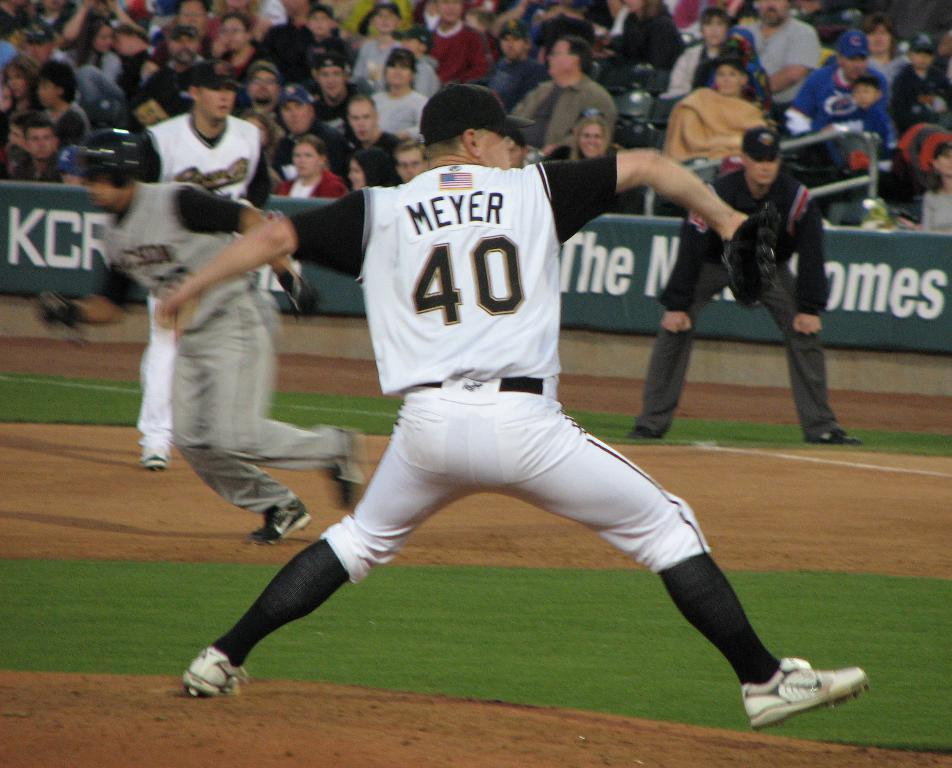<image>
Describe the image concisely. Meyer jersey worn by a baseball player who is playing on a field 